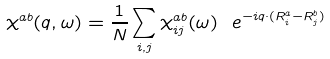<formula> <loc_0><loc_0><loc_500><loc_500>\chi ^ { a b } ( { q } , \omega ) = \frac { 1 } { N } \sum _ { i , j } \chi ^ { a b } _ { i j } ( \omega ) \ e ^ { - i { q } \cdot ( { R } _ { i } ^ { a } - { R } _ { j } ^ { b } ) }</formula> 